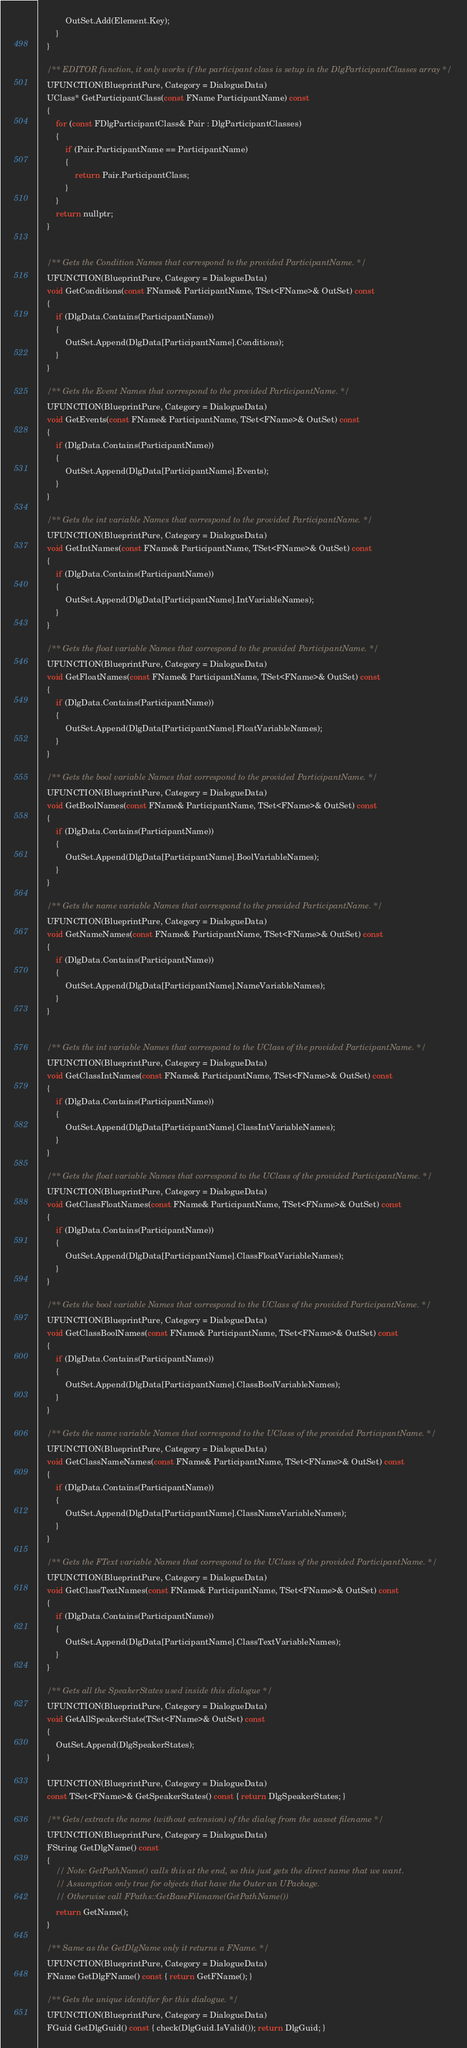Convert code to text. <code><loc_0><loc_0><loc_500><loc_500><_C_>			OutSet.Add(Element.Key);
		}
	}

	/** EDITOR function, it only works if the participant class is setup in the DlgParticipantClasses array */
	UFUNCTION(BlueprintPure, Category = DialogueData)
	UClass* GetParticipantClass(const FName ParticipantName) const
	{
		for (const FDlgParticipantClass& Pair : DlgParticipantClasses)
		{
			if (Pair.ParticipantName == ParticipantName)
			{
				return Pair.ParticipantClass;
			}
		}
		return nullptr;
	}


	/** Gets the Condition Names that correspond to the provided ParticipantName. */
	UFUNCTION(BlueprintPure, Category = DialogueData)
	void GetConditions(const FName& ParticipantName, TSet<FName>& OutSet) const
	{
		if (DlgData.Contains(ParticipantName))
		{
			OutSet.Append(DlgData[ParticipantName].Conditions);
		}
	}

	/** Gets the Event Names that correspond to the provided ParticipantName. */
	UFUNCTION(BlueprintPure, Category = DialogueData)
	void GetEvents(const FName& ParticipantName, TSet<FName>& OutSet) const
	{
		if (DlgData.Contains(ParticipantName))
		{
			OutSet.Append(DlgData[ParticipantName].Events);
		}
	}

	/** Gets the int variable Names that correspond to the provided ParticipantName. */
	UFUNCTION(BlueprintPure, Category = DialogueData)
	void GetIntNames(const FName& ParticipantName, TSet<FName>& OutSet) const
	{
		if (DlgData.Contains(ParticipantName))
		{
			OutSet.Append(DlgData[ParticipantName].IntVariableNames);
		}
	}

	/** Gets the float variable Names that correspond to the provided ParticipantName. */
	UFUNCTION(BlueprintPure, Category = DialogueData)
	void GetFloatNames(const FName& ParticipantName, TSet<FName>& OutSet) const
	{
		if (DlgData.Contains(ParticipantName))
		{
			OutSet.Append(DlgData[ParticipantName].FloatVariableNames);
		}
	}

	/** Gets the bool variable Names that correspond to the provided ParticipantName. */
	UFUNCTION(BlueprintPure, Category = DialogueData)
	void GetBoolNames(const FName& ParticipantName, TSet<FName>& OutSet) const
	{
		if (DlgData.Contains(ParticipantName))
		{
			OutSet.Append(DlgData[ParticipantName].BoolVariableNames);
		}
	}

	/** Gets the name variable Names that correspond to the provided ParticipantName. */
	UFUNCTION(BlueprintPure, Category = DialogueData)
	void GetNameNames(const FName& ParticipantName, TSet<FName>& OutSet) const
	{
		if (DlgData.Contains(ParticipantName))
		{
			OutSet.Append(DlgData[ParticipantName].NameVariableNames);
		}
	}


	/** Gets the int variable Names that correspond to the UClass of the provided ParticipantName. */
	UFUNCTION(BlueprintPure, Category = DialogueData)
	void GetClassIntNames(const FName& ParticipantName, TSet<FName>& OutSet) const
	{
		if (DlgData.Contains(ParticipantName))
		{
			OutSet.Append(DlgData[ParticipantName].ClassIntVariableNames);
		}
	}

	/** Gets the float variable Names that correspond to the UClass of the provided ParticipantName. */
	UFUNCTION(BlueprintPure, Category = DialogueData)
	void GetClassFloatNames(const FName& ParticipantName, TSet<FName>& OutSet) const
	{
		if (DlgData.Contains(ParticipantName))
		{
			OutSet.Append(DlgData[ParticipantName].ClassFloatVariableNames);
		}
	}

	/** Gets the bool variable Names that correspond to the UClass of the provided ParticipantName. */
	UFUNCTION(BlueprintPure, Category = DialogueData)
	void GetClassBoolNames(const FName& ParticipantName, TSet<FName>& OutSet) const
	{
		if (DlgData.Contains(ParticipantName))
		{
			OutSet.Append(DlgData[ParticipantName].ClassBoolVariableNames);
		}
	}

	/** Gets the name variable Names that correspond to the UClass of the provided ParticipantName. */
	UFUNCTION(BlueprintPure, Category = DialogueData)
	void GetClassNameNames(const FName& ParticipantName, TSet<FName>& OutSet) const
	{
		if (DlgData.Contains(ParticipantName))
		{
			OutSet.Append(DlgData[ParticipantName].ClassNameVariableNames);
		}
	}

	/** Gets the FText variable Names that correspond to the UClass of the provided ParticipantName. */
	UFUNCTION(BlueprintPure, Category = DialogueData)
	void GetClassTextNames(const FName& ParticipantName, TSet<FName>& OutSet) const
	{
		if (DlgData.Contains(ParticipantName))
		{
			OutSet.Append(DlgData[ParticipantName].ClassTextVariableNames);
		}
	}

	/** Gets all the SpeakerStates used inside this dialogue */
	UFUNCTION(BlueprintPure, Category = DialogueData)
	void GetAllSpeakerState(TSet<FName>& OutSet) const
	{
		OutSet.Append(DlgSpeakerStates);
	}

	UFUNCTION(BlueprintPure, Category = DialogueData)
	const TSet<FName>& GetSpeakerStates() const { return DlgSpeakerStates; }

	/** Gets/extracts the name (without extension) of the dialog from the uasset filename */
	UFUNCTION(BlueprintPure, Category = DialogueData)
	FString GetDlgName() const
	{
		// Note: GetPathName() calls this at the end, so this just gets the direct name that we want.
		// Assumption only true for objects that have the Outer an UPackage.
		// Otherwise call FPaths::GetBaseFilename(GetPathName())
		return GetName();
	}

	/** Same as the GetDlgName only it returns a FName. */
	UFUNCTION(BlueprintPure, Category = DialogueData)
	FName GetDlgFName() const { return GetFName(); }

	/** Gets the unique identifier for this dialogue. */
	UFUNCTION(BlueprintPure, Category = DialogueData)
	FGuid GetDlgGuid() const { check(DlgGuid.IsValid()); return DlgGuid; }
</code> 